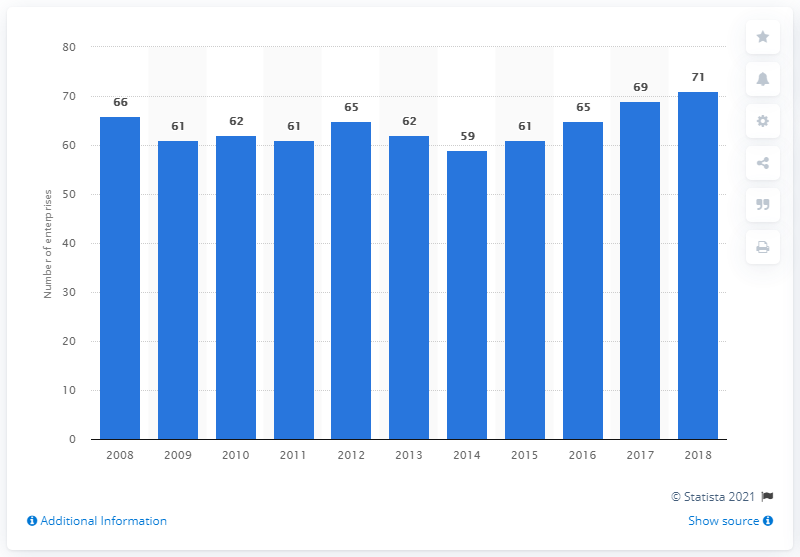Identify some key points in this picture. In 2015, there were 61 enterprises operating in Denmark's leather and related products industry. 